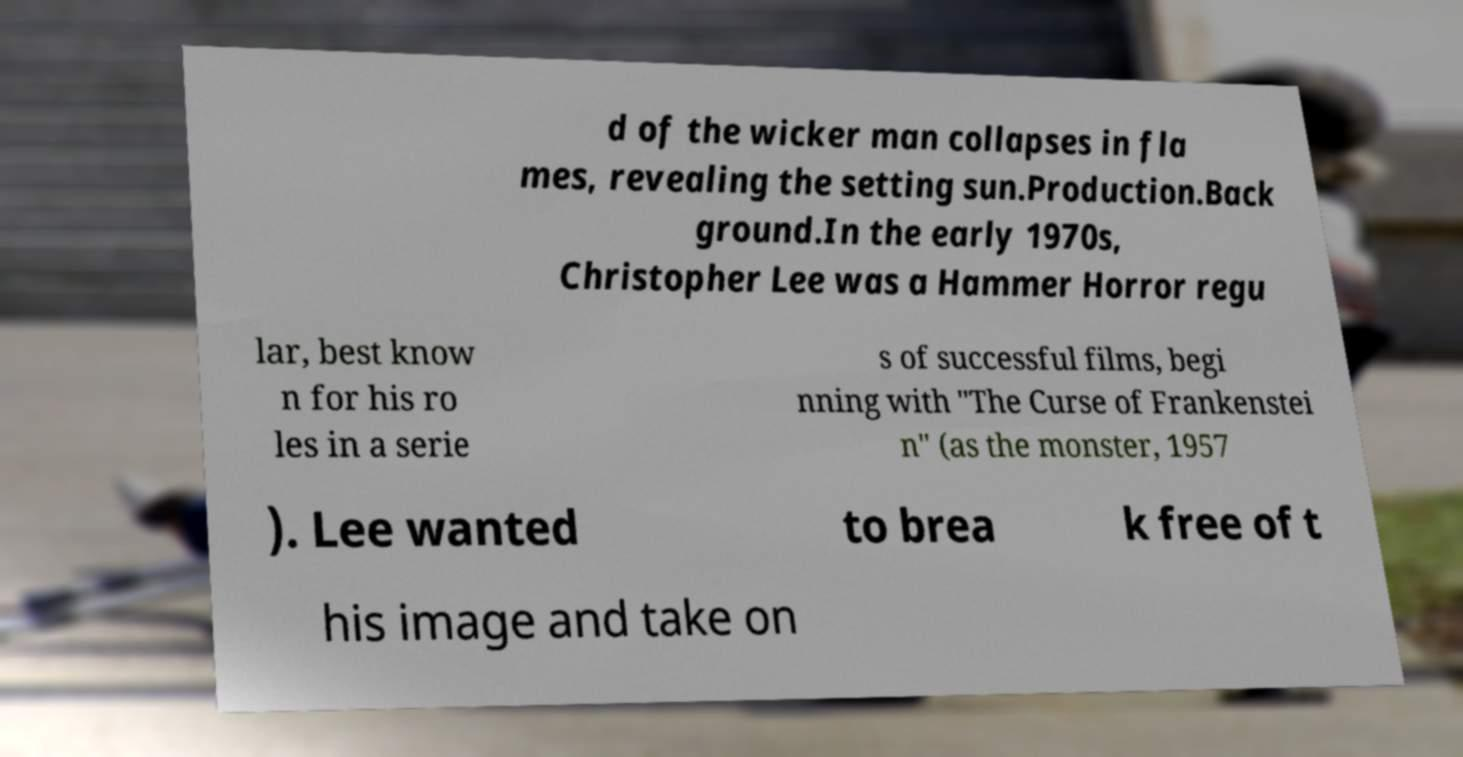There's text embedded in this image that I need extracted. Can you transcribe it verbatim? d of the wicker man collapses in fla mes, revealing the setting sun.Production.Back ground.In the early 1970s, Christopher Lee was a Hammer Horror regu lar, best know n for his ro les in a serie s of successful films, begi nning with "The Curse of Frankenstei n" (as the monster, 1957 ). Lee wanted to brea k free of t his image and take on 